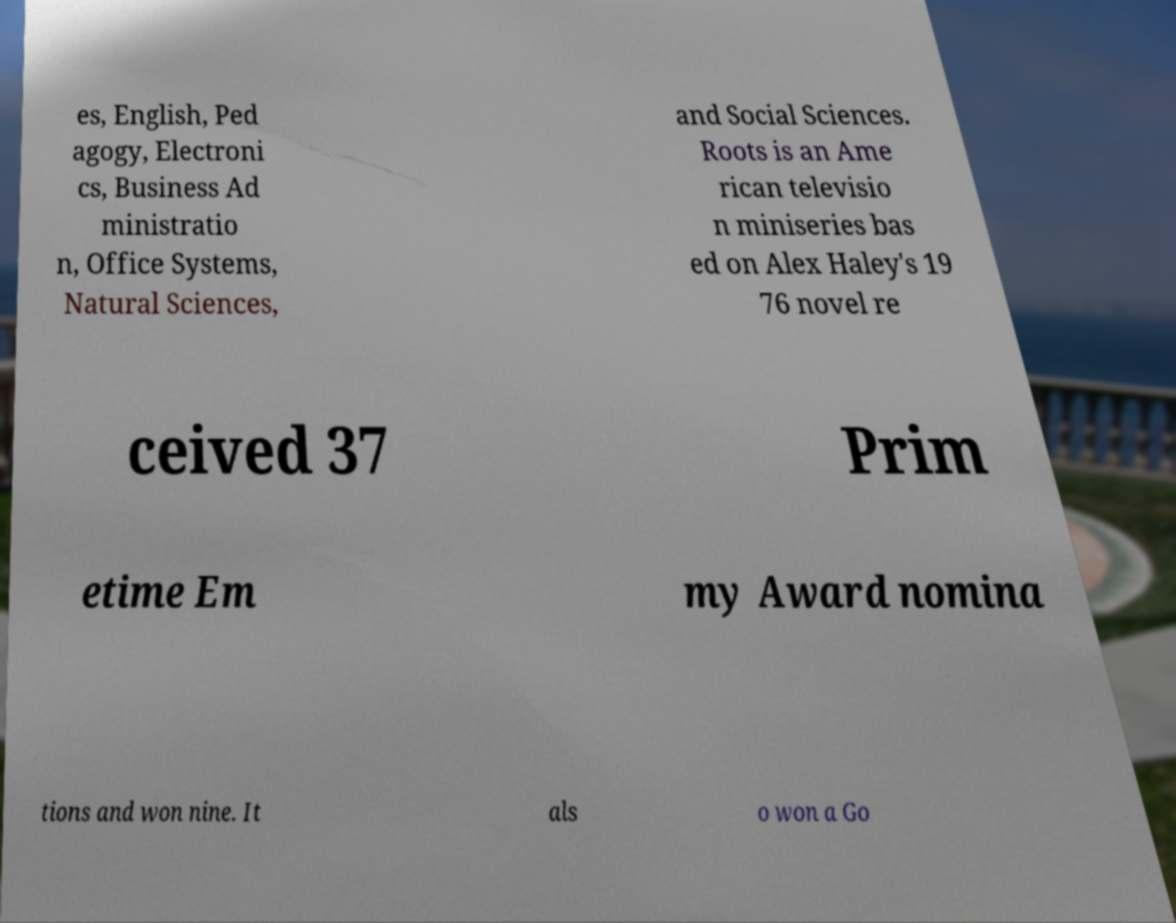There's text embedded in this image that I need extracted. Can you transcribe it verbatim? es, English, Ped agogy, Electroni cs, Business Ad ministratio n, Office Systems, Natural Sciences, and Social Sciences. Roots is an Ame rican televisio n miniseries bas ed on Alex Haley's 19 76 novel re ceived 37 Prim etime Em my Award nomina tions and won nine. It als o won a Go 